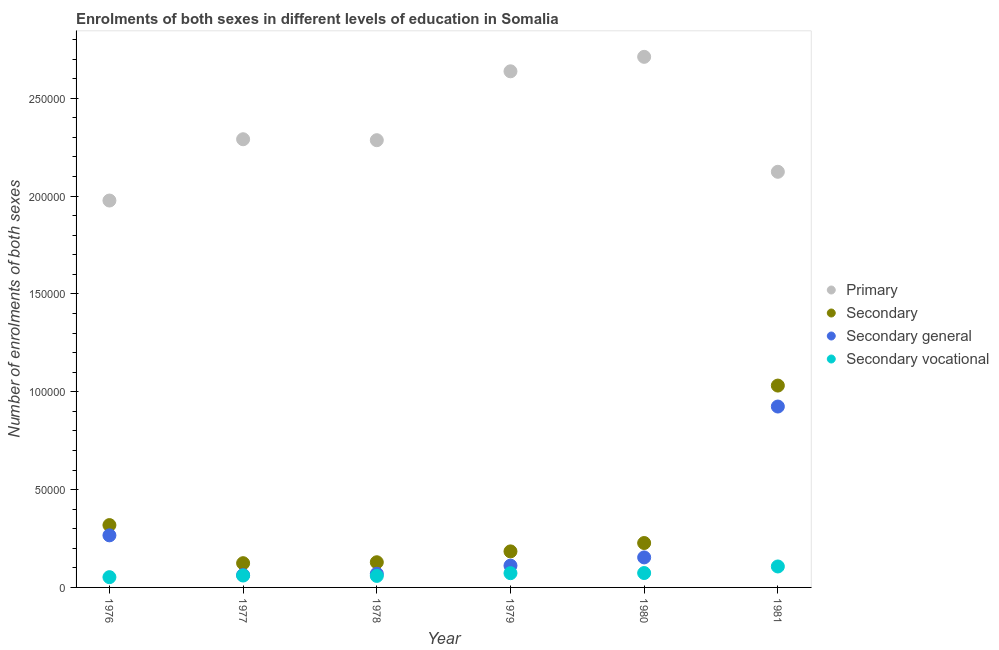What is the number of enrolments in secondary education in 1977?
Your answer should be very brief. 1.24e+04. Across all years, what is the maximum number of enrolments in secondary education?
Provide a short and direct response. 1.03e+05. Across all years, what is the minimum number of enrolments in primary education?
Ensure brevity in your answer.  1.98e+05. In which year was the number of enrolments in secondary vocational education minimum?
Provide a short and direct response. 1976. What is the total number of enrolments in secondary general education in the graph?
Your answer should be compact. 1.59e+05. What is the difference between the number of enrolments in primary education in 1979 and that in 1980?
Your answer should be very brief. -7388. What is the difference between the number of enrolments in primary education in 1981 and the number of enrolments in secondary vocational education in 1977?
Your response must be concise. 2.06e+05. What is the average number of enrolments in secondary general education per year?
Make the answer very short. 2.65e+04. In the year 1980, what is the difference between the number of enrolments in primary education and number of enrolments in secondary vocational education?
Make the answer very short. 2.64e+05. In how many years, is the number of enrolments in secondary education greater than 140000?
Your response must be concise. 0. What is the ratio of the number of enrolments in primary education in 1977 to that in 1980?
Provide a succinct answer. 0.84. What is the difference between the highest and the second highest number of enrolments in secondary education?
Your answer should be compact. 7.13e+04. What is the difference between the highest and the lowest number of enrolments in secondary general education?
Offer a terse response. 8.61e+04. Is the sum of the number of enrolments in primary education in 1977 and 1981 greater than the maximum number of enrolments in secondary education across all years?
Offer a very short reply. Yes. Is it the case that in every year, the sum of the number of enrolments in secondary vocational education and number of enrolments in secondary general education is greater than the sum of number of enrolments in primary education and number of enrolments in secondary education?
Provide a succinct answer. No. Is it the case that in every year, the sum of the number of enrolments in primary education and number of enrolments in secondary education is greater than the number of enrolments in secondary general education?
Provide a short and direct response. Yes. Is the number of enrolments in primary education strictly greater than the number of enrolments in secondary education over the years?
Offer a terse response. Yes. Is the number of enrolments in secondary education strictly less than the number of enrolments in secondary general education over the years?
Provide a succinct answer. No. How many years are there in the graph?
Keep it short and to the point. 6. What is the difference between two consecutive major ticks on the Y-axis?
Offer a very short reply. 5.00e+04. Does the graph contain any zero values?
Provide a short and direct response. No. What is the title of the graph?
Keep it short and to the point. Enrolments of both sexes in different levels of education in Somalia. Does "Compensation of employees" appear as one of the legend labels in the graph?
Your answer should be very brief. No. What is the label or title of the X-axis?
Make the answer very short. Year. What is the label or title of the Y-axis?
Your answer should be compact. Number of enrolments of both sexes. What is the Number of enrolments of both sexes in Primary in 1976?
Keep it short and to the point. 1.98e+05. What is the Number of enrolments of both sexes in Secondary in 1976?
Your response must be concise. 3.19e+04. What is the Number of enrolments of both sexes of Secondary general in 1976?
Keep it short and to the point. 2.66e+04. What is the Number of enrolments of both sexes of Secondary vocational in 1976?
Your answer should be very brief. 5246. What is the Number of enrolments of both sexes of Primary in 1977?
Offer a terse response. 2.29e+05. What is the Number of enrolments of both sexes of Secondary in 1977?
Ensure brevity in your answer.  1.24e+04. What is the Number of enrolments of both sexes in Secondary general in 1977?
Provide a short and direct response. 6308. What is the Number of enrolments of both sexes of Secondary vocational in 1977?
Offer a very short reply. 6081. What is the Number of enrolments of both sexes of Primary in 1978?
Offer a very short reply. 2.29e+05. What is the Number of enrolments of both sexes in Secondary in 1978?
Give a very brief answer. 1.29e+04. What is the Number of enrolments of both sexes of Secondary general in 1978?
Offer a very short reply. 6981. What is the Number of enrolments of both sexes of Secondary vocational in 1978?
Your response must be concise. 5888. What is the Number of enrolments of both sexes of Primary in 1979?
Ensure brevity in your answer.  2.64e+05. What is the Number of enrolments of both sexes of Secondary in 1979?
Provide a short and direct response. 1.84e+04. What is the Number of enrolments of both sexes of Secondary general in 1979?
Provide a succinct answer. 1.11e+04. What is the Number of enrolments of both sexes in Secondary vocational in 1979?
Provide a succinct answer. 7286. What is the Number of enrolments of both sexes of Primary in 1980?
Give a very brief answer. 2.71e+05. What is the Number of enrolments of both sexes of Secondary in 1980?
Ensure brevity in your answer.  2.27e+04. What is the Number of enrolments of both sexes in Secondary general in 1980?
Offer a very short reply. 1.53e+04. What is the Number of enrolments of both sexes of Secondary vocational in 1980?
Provide a succinct answer. 7353. What is the Number of enrolments of both sexes of Primary in 1981?
Offer a terse response. 2.12e+05. What is the Number of enrolments of both sexes in Secondary in 1981?
Make the answer very short. 1.03e+05. What is the Number of enrolments of both sexes of Secondary general in 1981?
Your answer should be compact. 9.24e+04. What is the Number of enrolments of both sexes of Secondary vocational in 1981?
Your answer should be compact. 1.07e+04. Across all years, what is the maximum Number of enrolments of both sexes of Primary?
Make the answer very short. 2.71e+05. Across all years, what is the maximum Number of enrolments of both sexes in Secondary?
Make the answer very short. 1.03e+05. Across all years, what is the maximum Number of enrolments of both sexes of Secondary general?
Your response must be concise. 9.24e+04. Across all years, what is the maximum Number of enrolments of both sexes of Secondary vocational?
Offer a very short reply. 1.07e+04. Across all years, what is the minimum Number of enrolments of both sexes of Primary?
Ensure brevity in your answer.  1.98e+05. Across all years, what is the minimum Number of enrolments of both sexes of Secondary?
Keep it short and to the point. 1.24e+04. Across all years, what is the minimum Number of enrolments of both sexes in Secondary general?
Your answer should be compact. 6308. Across all years, what is the minimum Number of enrolments of both sexes of Secondary vocational?
Offer a very short reply. 5246. What is the total Number of enrolments of both sexes of Primary in the graph?
Ensure brevity in your answer.  1.40e+06. What is the total Number of enrolments of both sexes of Secondary in the graph?
Offer a terse response. 2.01e+05. What is the total Number of enrolments of both sexes of Secondary general in the graph?
Keep it short and to the point. 1.59e+05. What is the total Number of enrolments of both sexes of Secondary vocational in the graph?
Give a very brief answer. 4.26e+04. What is the difference between the Number of enrolments of both sexes in Primary in 1976 and that in 1977?
Keep it short and to the point. -3.13e+04. What is the difference between the Number of enrolments of both sexes of Secondary in 1976 and that in 1977?
Make the answer very short. 1.95e+04. What is the difference between the Number of enrolments of both sexes in Secondary general in 1976 and that in 1977?
Provide a short and direct response. 2.03e+04. What is the difference between the Number of enrolments of both sexes in Secondary vocational in 1976 and that in 1977?
Provide a succinct answer. -835. What is the difference between the Number of enrolments of both sexes in Primary in 1976 and that in 1978?
Make the answer very short. -3.08e+04. What is the difference between the Number of enrolments of both sexes in Secondary in 1976 and that in 1978?
Your answer should be compact. 1.90e+04. What is the difference between the Number of enrolments of both sexes in Secondary general in 1976 and that in 1978?
Give a very brief answer. 1.96e+04. What is the difference between the Number of enrolments of both sexes of Secondary vocational in 1976 and that in 1978?
Provide a succinct answer. -642. What is the difference between the Number of enrolments of both sexes of Primary in 1976 and that in 1979?
Give a very brief answer. -6.60e+04. What is the difference between the Number of enrolments of both sexes in Secondary in 1976 and that in 1979?
Make the answer very short. 1.34e+04. What is the difference between the Number of enrolments of both sexes in Secondary general in 1976 and that in 1979?
Provide a succinct answer. 1.55e+04. What is the difference between the Number of enrolments of both sexes in Secondary vocational in 1976 and that in 1979?
Offer a terse response. -2040. What is the difference between the Number of enrolments of both sexes of Primary in 1976 and that in 1980?
Your answer should be very brief. -7.34e+04. What is the difference between the Number of enrolments of both sexes of Secondary in 1976 and that in 1980?
Provide a short and direct response. 9166. What is the difference between the Number of enrolments of both sexes of Secondary general in 1976 and that in 1980?
Offer a terse response. 1.13e+04. What is the difference between the Number of enrolments of both sexes in Secondary vocational in 1976 and that in 1980?
Your answer should be compact. -2107. What is the difference between the Number of enrolments of both sexes in Primary in 1976 and that in 1981?
Offer a very short reply. -1.47e+04. What is the difference between the Number of enrolments of both sexes of Secondary in 1976 and that in 1981?
Make the answer very short. -7.13e+04. What is the difference between the Number of enrolments of both sexes of Secondary general in 1976 and that in 1981?
Make the answer very short. -6.58e+04. What is the difference between the Number of enrolments of both sexes in Secondary vocational in 1976 and that in 1981?
Make the answer very short. -5463. What is the difference between the Number of enrolments of both sexes of Primary in 1977 and that in 1978?
Keep it short and to the point. 486. What is the difference between the Number of enrolments of both sexes of Secondary in 1977 and that in 1978?
Offer a very short reply. -480. What is the difference between the Number of enrolments of both sexes of Secondary general in 1977 and that in 1978?
Make the answer very short. -673. What is the difference between the Number of enrolments of both sexes in Secondary vocational in 1977 and that in 1978?
Provide a short and direct response. 193. What is the difference between the Number of enrolments of both sexes of Primary in 1977 and that in 1979?
Make the answer very short. -3.47e+04. What is the difference between the Number of enrolments of both sexes in Secondary in 1977 and that in 1979?
Offer a very short reply. -6027. What is the difference between the Number of enrolments of both sexes in Secondary general in 1977 and that in 1979?
Ensure brevity in your answer.  -4822. What is the difference between the Number of enrolments of both sexes in Secondary vocational in 1977 and that in 1979?
Your answer should be very brief. -1205. What is the difference between the Number of enrolments of both sexes of Primary in 1977 and that in 1980?
Give a very brief answer. -4.21e+04. What is the difference between the Number of enrolments of both sexes of Secondary in 1977 and that in 1980?
Your answer should be very brief. -1.03e+04. What is the difference between the Number of enrolments of both sexes in Secondary general in 1977 and that in 1980?
Provide a succinct answer. -9030. What is the difference between the Number of enrolments of both sexes in Secondary vocational in 1977 and that in 1980?
Your response must be concise. -1272. What is the difference between the Number of enrolments of both sexes in Primary in 1977 and that in 1981?
Your answer should be very brief. 1.66e+04. What is the difference between the Number of enrolments of both sexes of Secondary in 1977 and that in 1981?
Make the answer very short. -9.08e+04. What is the difference between the Number of enrolments of both sexes in Secondary general in 1977 and that in 1981?
Provide a succinct answer. -8.61e+04. What is the difference between the Number of enrolments of both sexes of Secondary vocational in 1977 and that in 1981?
Give a very brief answer. -4628. What is the difference between the Number of enrolments of both sexes of Primary in 1978 and that in 1979?
Your answer should be compact. -3.52e+04. What is the difference between the Number of enrolments of both sexes in Secondary in 1978 and that in 1979?
Your answer should be very brief. -5547. What is the difference between the Number of enrolments of both sexes in Secondary general in 1978 and that in 1979?
Ensure brevity in your answer.  -4149. What is the difference between the Number of enrolments of both sexes in Secondary vocational in 1978 and that in 1979?
Keep it short and to the point. -1398. What is the difference between the Number of enrolments of both sexes in Primary in 1978 and that in 1980?
Ensure brevity in your answer.  -4.26e+04. What is the difference between the Number of enrolments of both sexes of Secondary in 1978 and that in 1980?
Provide a succinct answer. -9822. What is the difference between the Number of enrolments of both sexes of Secondary general in 1978 and that in 1980?
Offer a very short reply. -8357. What is the difference between the Number of enrolments of both sexes of Secondary vocational in 1978 and that in 1980?
Offer a terse response. -1465. What is the difference between the Number of enrolments of both sexes in Primary in 1978 and that in 1981?
Offer a very short reply. 1.61e+04. What is the difference between the Number of enrolments of both sexes in Secondary in 1978 and that in 1981?
Make the answer very short. -9.03e+04. What is the difference between the Number of enrolments of both sexes in Secondary general in 1978 and that in 1981?
Your answer should be compact. -8.55e+04. What is the difference between the Number of enrolments of both sexes in Secondary vocational in 1978 and that in 1981?
Provide a short and direct response. -4821. What is the difference between the Number of enrolments of both sexes of Primary in 1979 and that in 1980?
Your answer should be compact. -7388. What is the difference between the Number of enrolments of both sexes of Secondary in 1979 and that in 1980?
Keep it short and to the point. -4275. What is the difference between the Number of enrolments of both sexes of Secondary general in 1979 and that in 1980?
Your answer should be compact. -4208. What is the difference between the Number of enrolments of both sexes of Secondary vocational in 1979 and that in 1980?
Your answer should be very brief. -67. What is the difference between the Number of enrolments of both sexes in Primary in 1979 and that in 1981?
Keep it short and to the point. 5.14e+04. What is the difference between the Number of enrolments of both sexes in Secondary in 1979 and that in 1981?
Keep it short and to the point. -8.47e+04. What is the difference between the Number of enrolments of both sexes in Secondary general in 1979 and that in 1981?
Provide a succinct answer. -8.13e+04. What is the difference between the Number of enrolments of both sexes of Secondary vocational in 1979 and that in 1981?
Offer a terse response. -3423. What is the difference between the Number of enrolments of both sexes in Primary in 1980 and that in 1981?
Provide a succinct answer. 5.87e+04. What is the difference between the Number of enrolments of both sexes in Secondary in 1980 and that in 1981?
Ensure brevity in your answer.  -8.05e+04. What is the difference between the Number of enrolments of both sexes in Secondary general in 1980 and that in 1981?
Give a very brief answer. -7.71e+04. What is the difference between the Number of enrolments of both sexes of Secondary vocational in 1980 and that in 1981?
Provide a short and direct response. -3356. What is the difference between the Number of enrolments of both sexes in Primary in 1976 and the Number of enrolments of both sexes in Secondary in 1977?
Your answer should be very brief. 1.85e+05. What is the difference between the Number of enrolments of both sexes in Primary in 1976 and the Number of enrolments of both sexes in Secondary general in 1977?
Your answer should be very brief. 1.91e+05. What is the difference between the Number of enrolments of both sexes in Primary in 1976 and the Number of enrolments of both sexes in Secondary vocational in 1977?
Your response must be concise. 1.92e+05. What is the difference between the Number of enrolments of both sexes in Secondary in 1976 and the Number of enrolments of both sexes in Secondary general in 1977?
Your answer should be very brief. 2.55e+04. What is the difference between the Number of enrolments of both sexes in Secondary in 1976 and the Number of enrolments of both sexes in Secondary vocational in 1977?
Provide a short and direct response. 2.58e+04. What is the difference between the Number of enrolments of both sexes in Secondary general in 1976 and the Number of enrolments of both sexes in Secondary vocational in 1977?
Your answer should be compact. 2.05e+04. What is the difference between the Number of enrolments of both sexes of Primary in 1976 and the Number of enrolments of both sexes of Secondary in 1978?
Ensure brevity in your answer.  1.85e+05. What is the difference between the Number of enrolments of both sexes in Primary in 1976 and the Number of enrolments of both sexes in Secondary general in 1978?
Offer a terse response. 1.91e+05. What is the difference between the Number of enrolments of both sexes in Primary in 1976 and the Number of enrolments of both sexes in Secondary vocational in 1978?
Make the answer very short. 1.92e+05. What is the difference between the Number of enrolments of both sexes in Secondary in 1976 and the Number of enrolments of both sexes in Secondary general in 1978?
Your answer should be compact. 2.49e+04. What is the difference between the Number of enrolments of both sexes in Secondary in 1976 and the Number of enrolments of both sexes in Secondary vocational in 1978?
Ensure brevity in your answer.  2.60e+04. What is the difference between the Number of enrolments of both sexes in Secondary general in 1976 and the Number of enrolments of both sexes in Secondary vocational in 1978?
Your answer should be very brief. 2.07e+04. What is the difference between the Number of enrolments of both sexes of Primary in 1976 and the Number of enrolments of both sexes of Secondary in 1979?
Ensure brevity in your answer.  1.79e+05. What is the difference between the Number of enrolments of both sexes of Primary in 1976 and the Number of enrolments of both sexes of Secondary general in 1979?
Provide a short and direct response. 1.87e+05. What is the difference between the Number of enrolments of both sexes of Primary in 1976 and the Number of enrolments of both sexes of Secondary vocational in 1979?
Your response must be concise. 1.90e+05. What is the difference between the Number of enrolments of both sexes of Secondary in 1976 and the Number of enrolments of both sexes of Secondary general in 1979?
Your answer should be very brief. 2.07e+04. What is the difference between the Number of enrolments of both sexes in Secondary in 1976 and the Number of enrolments of both sexes in Secondary vocational in 1979?
Make the answer very short. 2.46e+04. What is the difference between the Number of enrolments of both sexes of Secondary general in 1976 and the Number of enrolments of both sexes of Secondary vocational in 1979?
Offer a very short reply. 1.93e+04. What is the difference between the Number of enrolments of both sexes in Primary in 1976 and the Number of enrolments of both sexes in Secondary in 1980?
Your response must be concise. 1.75e+05. What is the difference between the Number of enrolments of both sexes of Primary in 1976 and the Number of enrolments of both sexes of Secondary general in 1980?
Your answer should be very brief. 1.82e+05. What is the difference between the Number of enrolments of both sexes in Primary in 1976 and the Number of enrolments of both sexes in Secondary vocational in 1980?
Give a very brief answer. 1.90e+05. What is the difference between the Number of enrolments of both sexes of Secondary in 1976 and the Number of enrolments of both sexes of Secondary general in 1980?
Make the answer very short. 1.65e+04. What is the difference between the Number of enrolments of both sexes in Secondary in 1976 and the Number of enrolments of both sexes in Secondary vocational in 1980?
Provide a succinct answer. 2.45e+04. What is the difference between the Number of enrolments of both sexes of Secondary general in 1976 and the Number of enrolments of both sexes of Secondary vocational in 1980?
Provide a succinct answer. 1.93e+04. What is the difference between the Number of enrolments of both sexes of Primary in 1976 and the Number of enrolments of both sexes of Secondary in 1981?
Keep it short and to the point. 9.46e+04. What is the difference between the Number of enrolments of both sexes of Primary in 1976 and the Number of enrolments of both sexes of Secondary general in 1981?
Offer a terse response. 1.05e+05. What is the difference between the Number of enrolments of both sexes of Primary in 1976 and the Number of enrolments of both sexes of Secondary vocational in 1981?
Offer a terse response. 1.87e+05. What is the difference between the Number of enrolments of both sexes in Secondary in 1976 and the Number of enrolments of both sexes in Secondary general in 1981?
Provide a short and direct response. -6.06e+04. What is the difference between the Number of enrolments of both sexes in Secondary in 1976 and the Number of enrolments of both sexes in Secondary vocational in 1981?
Your answer should be compact. 2.11e+04. What is the difference between the Number of enrolments of both sexes in Secondary general in 1976 and the Number of enrolments of both sexes in Secondary vocational in 1981?
Provide a succinct answer. 1.59e+04. What is the difference between the Number of enrolments of both sexes in Primary in 1977 and the Number of enrolments of both sexes in Secondary in 1978?
Keep it short and to the point. 2.16e+05. What is the difference between the Number of enrolments of both sexes of Primary in 1977 and the Number of enrolments of both sexes of Secondary general in 1978?
Offer a very short reply. 2.22e+05. What is the difference between the Number of enrolments of both sexes of Primary in 1977 and the Number of enrolments of both sexes of Secondary vocational in 1978?
Provide a short and direct response. 2.23e+05. What is the difference between the Number of enrolments of both sexes of Secondary in 1977 and the Number of enrolments of both sexes of Secondary general in 1978?
Your answer should be compact. 5408. What is the difference between the Number of enrolments of both sexes in Secondary in 1977 and the Number of enrolments of both sexes in Secondary vocational in 1978?
Offer a very short reply. 6501. What is the difference between the Number of enrolments of both sexes in Secondary general in 1977 and the Number of enrolments of both sexes in Secondary vocational in 1978?
Offer a terse response. 420. What is the difference between the Number of enrolments of both sexes in Primary in 1977 and the Number of enrolments of both sexes in Secondary in 1979?
Your answer should be compact. 2.11e+05. What is the difference between the Number of enrolments of both sexes in Primary in 1977 and the Number of enrolments of both sexes in Secondary general in 1979?
Your answer should be compact. 2.18e+05. What is the difference between the Number of enrolments of both sexes of Primary in 1977 and the Number of enrolments of both sexes of Secondary vocational in 1979?
Provide a succinct answer. 2.22e+05. What is the difference between the Number of enrolments of both sexes of Secondary in 1977 and the Number of enrolments of both sexes of Secondary general in 1979?
Your answer should be compact. 1259. What is the difference between the Number of enrolments of both sexes in Secondary in 1977 and the Number of enrolments of both sexes in Secondary vocational in 1979?
Make the answer very short. 5103. What is the difference between the Number of enrolments of both sexes of Secondary general in 1977 and the Number of enrolments of both sexes of Secondary vocational in 1979?
Provide a succinct answer. -978. What is the difference between the Number of enrolments of both sexes in Primary in 1977 and the Number of enrolments of both sexes in Secondary in 1980?
Make the answer very short. 2.06e+05. What is the difference between the Number of enrolments of both sexes in Primary in 1977 and the Number of enrolments of both sexes in Secondary general in 1980?
Your response must be concise. 2.14e+05. What is the difference between the Number of enrolments of both sexes of Primary in 1977 and the Number of enrolments of both sexes of Secondary vocational in 1980?
Your answer should be very brief. 2.22e+05. What is the difference between the Number of enrolments of both sexes of Secondary in 1977 and the Number of enrolments of both sexes of Secondary general in 1980?
Provide a succinct answer. -2949. What is the difference between the Number of enrolments of both sexes in Secondary in 1977 and the Number of enrolments of both sexes in Secondary vocational in 1980?
Give a very brief answer. 5036. What is the difference between the Number of enrolments of both sexes in Secondary general in 1977 and the Number of enrolments of both sexes in Secondary vocational in 1980?
Your response must be concise. -1045. What is the difference between the Number of enrolments of both sexes of Primary in 1977 and the Number of enrolments of both sexes of Secondary in 1981?
Offer a very short reply. 1.26e+05. What is the difference between the Number of enrolments of both sexes of Primary in 1977 and the Number of enrolments of both sexes of Secondary general in 1981?
Offer a very short reply. 1.37e+05. What is the difference between the Number of enrolments of both sexes of Primary in 1977 and the Number of enrolments of both sexes of Secondary vocational in 1981?
Provide a succinct answer. 2.18e+05. What is the difference between the Number of enrolments of both sexes of Secondary in 1977 and the Number of enrolments of both sexes of Secondary general in 1981?
Your response must be concise. -8.01e+04. What is the difference between the Number of enrolments of both sexes of Secondary in 1977 and the Number of enrolments of both sexes of Secondary vocational in 1981?
Make the answer very short. 1680. What is the difference between the Number of enrolments of both sexes of Secondary general in 1977 and the Number of enrolments of both sexes of Secondary vocational in 1981?
Your response must be concise. -4401. What is the difference between the Number of enrolments of both sexes in Primary in 1978 and the Number of enrolments of both sexes in Secondary in 1979?
Make the answer very short. 2.10e+05. What is the difference between the Number of enrolments of both sexes of Primary in 1978 and the Number of enrolments of both sexes of Secondary general in 1979?
Your response must be concise. 2.17e+05. What is the difference between the Number of enrolments of both sexes of Primary in 1978 and the Number of enrolments of both sexes of Secondary vocational in 1979?
Your answer should be compact. 2.21e+05. What is the difference between the Number of enrolments of both sexes in Secondary in 1978 and the Number of enrolments of both sexes in Secondary general in 1979?
Provide a succinct answer. 1739. What is the difference between the Number of enrolments of both sexes of Secondary in 1978 and the Number of enrolments of both sexes of Secondary vocational in 1979?
Your answer should be compact. 5583. What is the difference between the Number of enrolments of both sexes of Secondary general in 1978 and the Number of enrolments of both sexes of Secondary vocational in 1979?
Make the answer very short. -305. What is the difference between the Number of enrolments of both sexes of Primary in 1978 and the Number of enrolments of both sexes of Secondary in 1980?
Provide a short and direct response. 2.06e+05. What is the difference between the Number of enrolments of both sexes in Primary in 1978 and the Number of enrolments of both sexes in Secondary general in 1980?
Your answer should be compact. 2.13e+05. What is the difference between the Number of enrolments of both sexes of Primary in 1978 and the Number of enrolments of both sexes of Secondary vocational in 1980?
Provide a succinct answer. 2.21e+05. What is the difference between the Number of enrolments of both sexes of Secondary in 1978 and the Number of enrolments of both sexes of Secondary general in 1980?
Ensure brevity in your answer.  -2469. What is the difference between the Number of enrolments of both sexes in Secondary in 1978 and the Number of enrolments of both sexes in Secondary vocational in 1980?
Ensure brevity in your answer.  5516. What is the difference between the Number of enrolments of both sexes of Secondary general in 1978 and the Number of enrolments of both sexes of Secondary vocational in 1980?
Provide a succinct answer. -372. What is the difference between the Number of enrolments of both sexes in Primary in 1978 and the Number of enrolments of both sexes in Secondary in 1981?
Offer a terse response. 1.25e+05. What is the difference between the Number of enrolments of both sexes in Primary in 1978 and the Number of enrolments of both sexes in Secondary general in 1981?
Make the answer very short. 1.36e+05. What is the difference between the Number of enrolments of both sexes in Primary in 1978 and the Number of enrolments of both sexes in Secondary vocational in 1981?
Your response must be concise. 2.18e+05. What is the difference between the Number of enrolments of both sexes of Secondary in 1978 and the Number of enrolments of both sexes of Secondary general in 1981?
Give a very brief answer. -7.96e+04. What is the difference between the Number of enrolments of both sexes in Secondary in 1978 and the Number of enrolments of both sexes in Secondary vocational in 1981?
Offer a very short reply. 2160. What is the difference between the Number of enrolments of both sexes of Secondary general in 1978 and the Number of enrolments of both sexes of Secondary vocational in 1981?
Your answer should be very brief. -3728. What is the difference between the Number of enrolments of both sexes of Primary in 1979 and the Number of enrolments of both sexes of Secondary in 1980?
Your answer should be compact. 2.41e+05. What is the difference between the Number of enrolments of both sexes of Primary in 1979 and the Number of enrolments of both sexes of Secondary general in 1980?
Keep it short and to the point. 2.48e+05. What is the difference between the Number of enrolments of both sexes in Primary in 1979 and the Number of enrolments of both sexes in Secondary vocational in 1980?
Keep it short and to the point. 2.56e+05. What is the difference between the Number of enrolments of both sexes of Secondary in 1979 and the Number of enrolments of both sexes of Secondary general in 1980?
Make the answer very short. 3078. What is the difference between the Number of enrolments of both sexes in Secondary in 1979 and the Number of enrolments of both sexes in Secondary vocational in 1980?
Offer a terse response. 1.11e+04. What is the difference between the Number of enrolments of both sexes in Secondary general in 1979 and the Number of enrolments of both sexes in Secondary vocational in 1980?
Keep it short and to the point. 3777. What is the difference between the Number of enrolments of both sexes of Primary in 1979 and the Number of enrolments of both sexes of Secondary in 1981?
Your answer should be very brief. 1.61e+05. What is the difference between the Number of enrolments of both sexes of Primary in 1979 and the Number of enrolments of both sexes of Secondary general in 1981?
Your response must be concise. 1.71e+05. What is the difference between the Number of enrolments of both sexes of Primary in 1979 and the Number of enrolments of both sexes of Secondary vocational in 1981?
Provide a succinct answer. 2.53e+05. What is the difference between the Number of enrolments of both sexes of Secondary in 1979 and the Number of enrolments of both sexes of Secondary general in 1981?
Offer a terse response. -7.40e+04. What is the difference between the Number of enrolments of both sexes in Secondary in 1979 and the Number of enrolments of both sexes in Secondary vocational in 1981?
Offer a very short reply. 7707. What is the difference between the Number of enrolments of both sexes in Secondary general in 1979 and the Number of enrolments of both sexes in Secondary vocational in 1981?
Keep it short and to the point. 421. What is the difference between the Number of enrolments of both sexes of Primary in 1980 and the Number of enrolments of both sexes of Secondary in 1981?
Keep it short and to the point. 1.68e+05. What is the difference between the Number of enrolments of both sexes of Primary in 1980 and the Number of enrolments of both sexes of Secondary general in 1981?
Offer a terse response. 1.79e+05. What is the difference between the Number of enrolments of both sexes of Primary in 1980 and the Number of enrolments of both sexes of Secondary vocational in 1981?
Your answer should be compact. 2.60e+05. What is the difference between the Number of enrolments of both sexes in Secondary in 1980 and the Number of enrolments of both sexes in Secondary general in 1981?
Provide a short and direct response. -6.98e+04. What is the difference between the Number of enrolments of both sexes of Secondary in 1980 and the Number of enrolments of both sexes of Secondary vocational in 1981?
Make the answer very short. 1.20e+04. What is the difference between the Number of enrolments of both sexes of Secondary general in 1980 and the Number of enrolments of both sexes of Secondary vocational in 1981?
Offer a very short reply. 4629. What is the average Number of enrolments of both sexes of Primary per year?
Offer a terse response. 2.34e+05. What is the average Number of enrolments of both sexes in Secondary per year?
Provide a short and direct response. 3.36e+04. What is the average Number of enrolments of both sexes of Secondary general per year?
Give a very brief answer. 2.65e+04. What is the average Number of enrolments of both sexes in Secondary vocational per year?
Offer a very short reply. 7093.83. In the year 1976, what is the difference between the Number of enrolments of both sexes of Primary and Number of enrolments of both sexes of Secondary?
Provide a succinct answer. 1.66e+05. In the year 1976, what is the difference between the Number of enrolments of both sexes in Primary and Number of enrolments of both sexes in Secondary general?
Provide a short and direct response. 1.71e+05. In the year 1976, what is the difference between the Number of enrolments of both sexes in Primary and Number of enrolments of both sexes in Secondary vocational?
Your answer should be compact. 1.92e+05. In the year 1976, what is the difference between the Number of enrolments of both sexes in Secondary and Number of enrolments of both sexes in Secondary general?
Your answer should be compact. 5246. In the year 1976, what is the difference between the Number of enrolments of both sexes in Secondary and Number of enrolments of both sexes in Secondary vocational?
Ensure brevity in your answer.  2.66e+04. In the year 1976, what is the difference between the Number of enrolments of both sexes in Secondary general and Number of enrolments of both sexes in Secondary vocational?
Your answer should be very brief. 2.14e+04. In the year 1977, what is the difference between the Number of enrolments of both sexes of Primary and Number of enrolments of both sexes of Secondary?
Offer a terse response. 2.17e+05. In the year 1977, what is the difference between the Number of enrolments of both sexes in Primary and Number of enrolments of both sexes in Secondary general?
Give a very brief answer. 2.23e+05. In the year 1977, what is the difference between the Number of enrolments of both sexes of Primary and Number of enrolments of both sexes of Secondary vocational?
Ensure brevity in your answer.  2.23e+05. In the year 1977, what is the difference between the Number of enrolments of both sexes of Secondary and Number of enrolments of both sexes of Secondary general?
Ensure brevity in your answer.  6081. In the year 1977, what is the difference between the Number of enrolments of both sexes in Secondary and Number of enrolments of both sexes in Secondary vocational?
Offer a terse response. 6308. In the year 1977, what is the difference between the Number of enrolments of both sexes in Secondary general and Number of enrolments of both sexes in Secondary vocational?
Your answer should be very brief. 227. In the year 1978, what is the difference between the Number of enrolments of both sexes in Primary and Number of enrolments of both sexes in Secondary?
Your response must be concise. 2.16e+05. In the year 1978, what is the difference between the Number of enrolments of both sexes of Primary and Number of enrolments of both sexes of Secondary general?
Provide a succinct answer. 2.22e+05. In the year 1978, what is the difference between the Number of enrolments of both sexes in Primary and Number of enrolments of both sexes in Secondary vocational?
Provide a succinct answer. 2.23e+05. In the year 1978, what is the difference between the Number of enrolments of both sexes in Secondary and Number of enrolments of both sexes in Secondary general?
Provide a succinct answer. 5888. In the year 1978, what is the difference between the Number of enrolments of both sexes of Secondary and Number of enrolments of both sexes of Secondary vocational?
Keep it short and to the point. 6981. In the year 1978, what is the difference between the Number of enrolments of both sexes in Secondary general and Number of enrolments of both sexes in Secondary vocational?
Make the answer very short. 1093. In the year 1979, what is the difference between the Number of enrolments of both sexes in Primary and Number of enrolments of both sexes in Secondary?
Offer a terse response. 2.45e+05. In the year 1979, what is the difference between the Number of enrolments of both sexes of Primary and Number of enrolments of both sexes of Secondary general?
Provide a succinct answer. 2.53e+05. In the year 1979, what is the difference between the Number of enrolments of both sexes in Primary and Number of enrolments of both sexes in Secondary vocational?
Your response must be concise. 2.56e+05. In the year 1979, what is the difference between the Number of enrolments of both sexes of Secondary and Number of enrolments of both sexes of Secondary general?
Keep it short and to the point. 7286. In the year 1979, what is the difference between the Number of enrolments of both sexes in Secondary and Number of enrolments of both sexes in Secondary vocational?
Your answer should be compact. 1.11e+04. In the year 1979, what is the difference between the Number of enrolments of both sexes in Secondary general and Number of enrolments of both sexes in Secondary vocational?
Offer a terse response. 3844. In the year 1980, what is the difference between the Number of enrolments of both sexes in Primary and Number of enrolments of both sexes in Secondary?
Offer a terse response. 2.48e+05. In the year 1980, what is the difference between the Number of enrolments of both sexes of Primary and Number of enrolments of both sexes of Secondary general?
Ensure brevity in your answer.  2.56e+05. In the year 1980, what is the difference between the Number of enrolments of both sexes in Primary and Number of enrolments of both sexes in Secondary vocational?
Your answer should be compact. 2.64e+05. In the year 1980, what is the difference between the Number of enrolments of both sexes in Secondary and Number of enrolments of both sexes in Secondary general?
Offer a very short reply. 7353. In the year 1980, what is the difference between the Number of enrolments of both sexes of Secondary and Number of enrolments of both sexes of Secondary vocational?
Provide a short and direct response. 1.53e+04. In the year 1980, what is the difference between the Number of enrolments of both sexes of Secondary general and Number of enrolments of both sexes of Secondary vocational?
Offer a very short reply. 7985. In the year 1981, what is the difference between the Number of enrolments of both sexes in Primary and Number of enrolments of both sexes in Secondary?
Your answer should be compact. 1.09e+05. In the year 1981, what is the difference between the Number of enrolments of both sexes of Primary and Number of enrolments of both sexes of Secondary general?
Offer a terse response. 1.20e+05. In the year 1981, what is the difference between the Number of enrolments of both sexes in Primary and Number of enrolments of both sexes in Secondary vocational?
Give a very brief answer. 2.02e+05. In the year 1981, what is the difference between the Number of enrolments of both sexes of Secondary and Number of enrolments of both sexes of Secondary general?
Provide a short and direct response. 1.07e+04. In the year 1981, what is the difference between the Number of enrolments of both sexes in Secondary and Number of enrolments of both sexes in Secondary vocational?
Offer a terse response. 9.24e+04. In the year 1981, what is the difference between the Number of enrolments of both sexes in Secondary general and Number of enrolments of both sexes in Secondary vocational?
Your response must be concise. 8.17e+04. What is the ratio of the Number of enrolments of both sexes in Primary in 1976 to that in 1977?
Offer a very short reply. 0.86. What is the ratio of the Number of enrolments of both sexes of Secondary in 1976 to that in 1977?
Your response must be concise. 2.57. What is the ratio of the Number of enrolments of both sexes in Secondary general in 1976 to that in 1977?
Keep it short and to the point. 4.22. What is the ratio of the Number of enrolments of both sexes of Secondary vocational in 1976 to that in 1977?
Your response must be concise. 0.86. What is the ratio of the Number of enrolments of both sexes in Primary in 1976 to that in 1978?
Your answer should be very brief. 0.87. What is the ratio of the Number of enrolments of both sexes of Secondary in 1976 to that in 1978?
Your answer should be very brief. 2.48. What is the ratio of the Number of enrolments of both sexes in Secondary general in 1976 to that in 1978?
Make the answer very short. 3.81. What is the ratio of the Number of enrolments of both sexes in Secondary vocational in 1976 to that in 1978?
Offer a very short reply. 0.89. What is the ratio of the Number of enrolments of both sexes in Primary in 1976 to that in 1979?
Your response must be concise. 0.75. What is the ratio of the Number of enrolments of both sexes in Secondary in 1976 to that in 1979?
Make the answer very short. 1.73. What is the ratio of the Number of enrolments of both sexes of Secondary general in 1976 to that in 1979?
Your answer should be very brief. 2.39. What is the ratio of the Number of enrolments of both sexes of Secondary vocational in 1976 to that in 1979?
Provide a short and direct response. 0.72. What is the ratio of the Number of enrolments of both sexes of Primary in 1976 to that in 1980?
Your answer should be compact. 0.73. What is the ratio of the Number of enrolments of both sexes of Secondary in 1976 to that in 1980?
Ensure brevity in your answer.  1.4. What is the ratio of the Number of enrolments of both sexes in Secondary general in 1976 to that in 1980?
Ensure brevity in your answer.  1.74. What is the ratio of the Number of enrolments of both sexes in Secondary vocational in 1976 to that in 1980?
Keep it short and to the point. 0.71. What is the ratio of the Number of enrolments of both sexes in Primary in 1976 to that in 1981?
Provide a succinct answer. 0.93. What is the ratio of the Number of enrolments of both sexes of Secondary in 1976 to that in 1981?
Ensure brevity in your answer.  0.31. What is the ratio of the Number of enrolments of both sexes in Secondary general in 1976 to that in 1981?
Your answer should be compact. 0.29. What is the ratio of the Number of enrolments of both sexes in Secondary vocational in 1976 to that in 1981?
Provide a short and direct response. 0.49. What is the ratio of the Number of enrolments of both sexes of Secondary in 1977 to that in 1978?
Offer a terse response. 0.96. What is the ratio of the Number of enrolments of both sexes in Secondary general in 1977 to that in 1978?
Your response must be concise. 0.9. What is the ratio of the Number of enrolments of both sexes in Secondary vocational in 1977 to that in 1978?
Offer a very short reply. 1.03. What is the ratio of the Number of enrolments of both sexes in Primary in 1977 to that in 1979?
Keep it short and to the point. 0.87. What is the ratio of the Number of enrolments of both sexes of Secondary in 1977 to that in 1979?
Your answer should be very brief. 0.67. What is the ratio of the Number of enrolments of both sexes in Secondary general in 1977 to that in 1979?
Your answer should be very brief. 0.57. What is the ratio of the Number of enrolments of both sexes of Secondary vocational in 1977 to that in 1979?
Ensure brevity in your answer.  0.83. What is the ratio of the Number of enrolments of both sexes of Primary in 1977 to that in 1980?
Provide a succinct answer. 0.84. What is the ratio of the Number of enrolments of both sexes of Secondary in 1977 to that in 1980?
Make the answer very short. 0.55. What is the ratio of the Number of enrolments of both sexes in Secondary general in 1977 to that in 1980?
Your answer should be compact. 0.41. What is the ratio of the Number of enrolments of both sexes of Secondary vocational in 1977 to that in 1980?
Your answer should be very brief. 0.83. What is the ratio of the Number of enrolments of both sexes of Primary in 1977 to that in 1981?
Give a very brief answer. 1.08. What is the ratio of the Number of enrolments of both sexes in Secondary in 1977 to that in 1981?
Offer a terse response. 0.12. What is the ratio of the Number of enrolments of both sexes in Secondary general in 1977 to that in 1981?
Give a very brief answer. 0.07. What is the ratio of the Number of enrolments of both sexes of Secondary vocational in 1977 to that in 1981?
Ensure brevity in your answer.  0.57. What is the ratio of the Number of enrolments of both sexes of Primary in 1978 to that in 1979?
Provide a short and direct response. 0.87. What is the ratio of the Number of enrolments of both sexes in Secondary in 1978 to that in 1979?
Ensure brevity in your answer.  0.7. What is the ratio of the Number of enrolments of both sexes of Secondary general in 1978 to that in 1979?
Make the answer very short. 0.63. What is the ratio of the Number of enrolments of both sexes in Secondary vocational in 1978 to that in 1979?
Provide a short and direct response. 0.81. What is the ratio of the Number of enrolments of both sexes in Primary in 1978 to that in 1980?
Your answer should be compact. 0.84. What is the ratio of the Number of enrolments of both sexes of Secondary in 1978 to that in 1980?
Offer a very short reply. 0.57. What is the ratio of the Number of enrolments of both sexes in Secondary general in 1978 to that in 1980?
Provide a short and direct response. 0.46. What is the ratio of the Number of enrolments of both sexes of Secondary vocational in 1978 to that in 1980?
Keep it short and to the point. 0.8. What is the ratio of the Number of enrolments of both sexes in Primary in 1978 to that in 1981?
Offer a terse response. 1.08. What is the ratio of the Number of enrolments of both sexes of Secondary in 1978 to that in 1981?
Your response must be concise. 0.12. What is the ratio of the Number of enrolments of both sexes of Secondary general in 1978 to that in 1981?
Provide a succinct answer. 0.08. What is the ratio of the Number of enrolments of both sexes of Secondary vocational in 1978 to that in 1981?
Provide a short and direct response. 0.55. What is the ratio of the Number of enrolments of both sexes of Primary in 1979 to that in 1980?
Your answer should be very brief. 0.97. What is the ratio of the Number of enrolments of both sexes in Secondary in 1979 to that in 1980?
Your response must be concise. 0.81. What is the ratio of the Number of enrolments of both sexes of Secondary general in 1979 to that in 1980?
Provide a succinct answer. 0.73. What is the ratio of the Number of enrolments of both sexes in Secondary vocational in 1979 to that in 1980?
Your answer should be very brief. 0.99. What is the ratio of the Number of enrolments of both sexes of Primary in 1979 to that in 1981?
Your response must be concise. 1.24. What is the ratio of the Number of enrolments of both sexes of Secondary in 1979 to that in 1981?
Your answer should be very brief. 0.18. What is the ratio of the Number of enrolments of both sexes of Secondary general in 1979 to that in 1981?
Offer a terse response. 0.12. What is the ratio of the Number of enrolments of both sexes of Secondary vocational in 1979 to that in 1981?
Offer a very short reply. 0.68. What is the ratio of the Number of enrolments of both sexes in Primary in 1980 to that in 1981?
Offer a very short reply. 1.28. What is the ratio of the Number of enrolments of both sexes in Secondary in 1980 to that in 1981?
Offer a terse response. 0.22. What is the ratio of the Number of enrolments of both sexes in Secondary general in 1980 to that in 1981?
Provide a short and direct response. 0.17. What is the ratio of the Number of enrolments of both sexes of Secondary vocational in 1980 to that in 1981?
Provide a short and direct response. 0.69. What is the difference between the highest and the second highest Number of enrolments of both sexes in Primary?
Offer a terse response. 7388. What is the difference between the highest and the second highest Number of enrolments of both sexes of Secondary?
Give a very brief answer. 7.13e+04. What is the difference between the highest and the second highest Number of enrolments of both sexes in Secondary general?
Provide a short and direct response. 6.58e+04. What is the difference between the highest and the second highest Number of enrolments of both sexes of Secondary vocational?
Your answer should be very brief. 3356. What is the difference between the highest and the lowest Number of enrolments of both sexes of Primary?
Give a very brief answer. 7.34e+04. What is the difference between the highest and the lowest Number of enrolments of both sexes in Secondary?
Offer a terse response. 9.08e+04. What is the difference between the highest and the lowest Number of enrolments of both sexes of Secondary general?
Offer a terse response. 8.61e+04. What is the difference between the highest and the lowest Number of enrolments of both sexes of Secondary vocational?
Your answer should be very brief. 5463. 